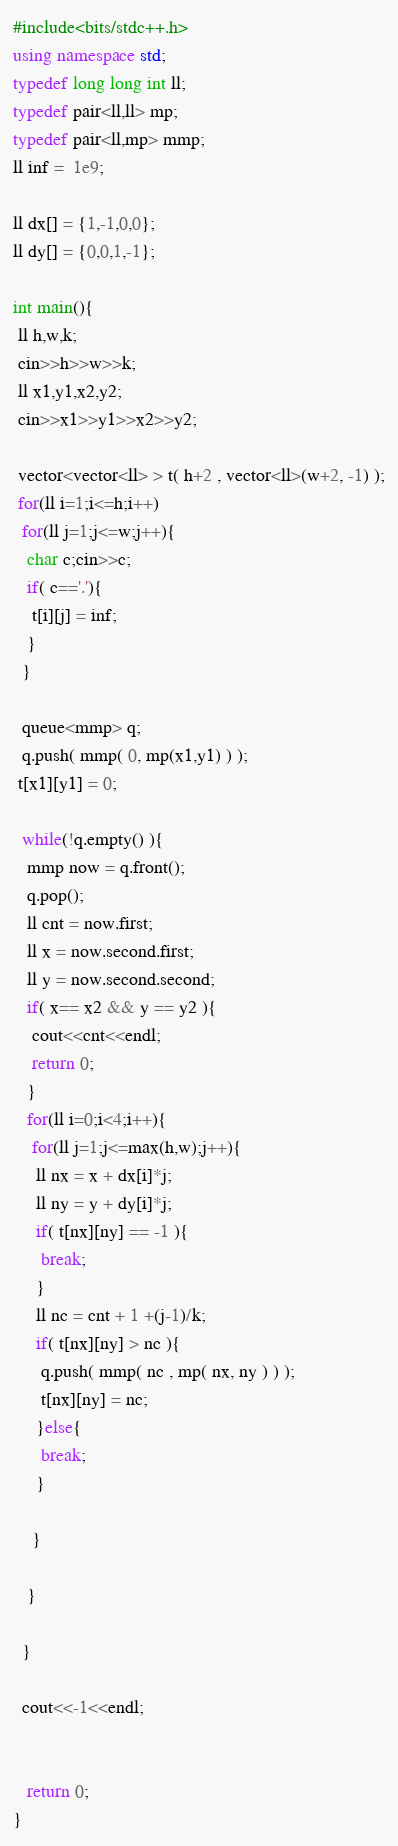Convert code to text. <code><loc_0><loc_0><loc_500><loc_500><_C++_>#include<bits/stdc++.h>
using namespace std;
typedef long long int ll;
typedef pair<ll,ll> mp;
typedef pair<ll,mp> mmp;
ll inf =  1e9;

ll dx[] = {1,-1,0,0};
ll dy[] = {0,0,1,-1};

int main(){
 ll h,w,k;
 cin>>h>>w>>k;
 ll x1,y1,x2,y2;
 cin>>x1>>y1>>x2>>y2;

 vector<vector<ll> > t( h+2 , vector<ll>(w+2, -1) );
 for(ll i=1;i<=h;i++)
  for(ll j=1;j<=w;j++){
   char c;cin>>c;
   if( c=='.'){
    t[i][j] = inf;
   }
  }

  queue<mmp> q;
  q.push( mmp( 0, mp(x1,y1) ) );
 t[x1][y1] = 0;
  
  while(!q.empty() ){
   mmp now = q.front();
   q.pop();
   ll cnt = now.first;
   ll x = now.second.first;
   ll y = now.second.second;
   if( x== x2 && y == y2 ){
    cout<<cnt<<endl;
    return 0;
   }
   for(ll i=0;i<4;i++){
    for(ll j=1;j<=max(h,w);j++){
     ll nx = x + dx[i]*j;
     ll ny = y + dy[i]*j;
     if( t[nx][ny] == -1 ){
      break;
     }
     ll nc = cnt + 1 +(j-1)/k;
     if( t[nx][ny] > nc ){
      q.push( mmp( nc , mp( nx, ny ) ) );
      t[nx][ny] = nc;
     }else{
      break;
     }

    }

   }

  }

  cout<<-1<<endl;


   return 0;
}
</code> 